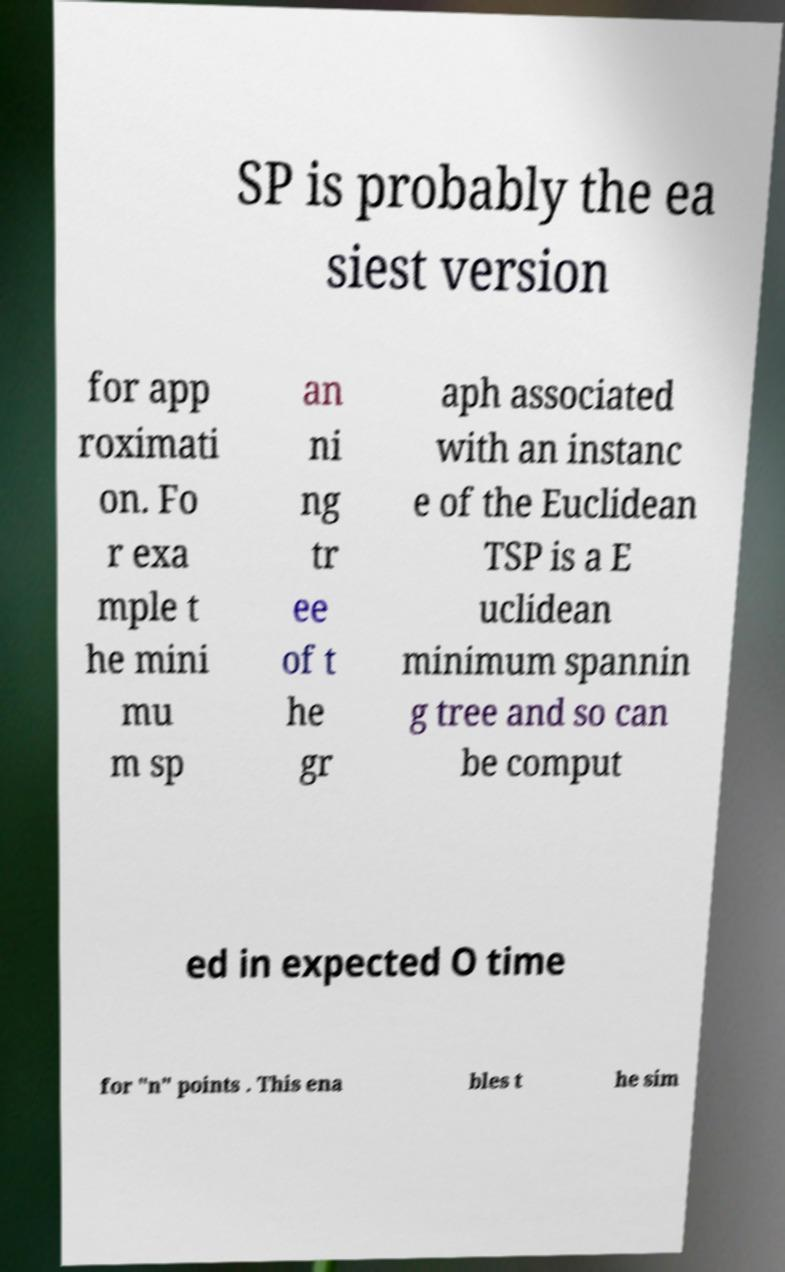Can you read and provide the text displayed in the image?This photo seems to have some interesting text. Can you extract and type it out for me? SP is probably the ea siest version for app roximati on. Fo r exa mple t he mini mu m sp an ni ng tr ee of t he gr aph associated with an instanc e of the Euclidean TSP is a E uclidean minimum spannin g tree and so can be comput ed in expected O time for "n" points . This ena bles t he sim 